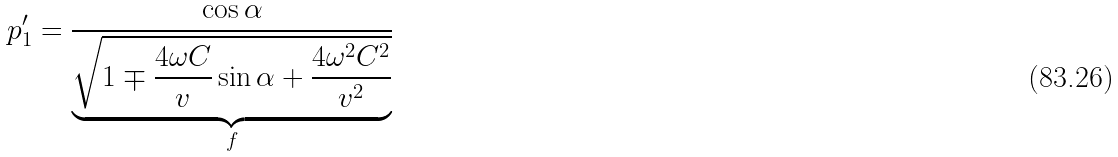<formula> <loc_0><loc_0><loc_500><loc_500>p ^ { \prime } _ { 1 } = \frac { \cos \alpha } { \underbrace { \sqrt { 1 \mp \frac { 4 \omega C } { v } \sin \alpha + \frac { 4 \omega ^ { 2 } C ^ { 2 } } { v ^ { 2 } } } } _ { f } }</formula> 